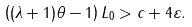<formula> <loc_0><loc_0><loc_500><loc_500>\left ( ( \lambda + 1 ) \theta - 1 \right ) L _ { 0 } > c + 4 \varepsilon .</formula> 